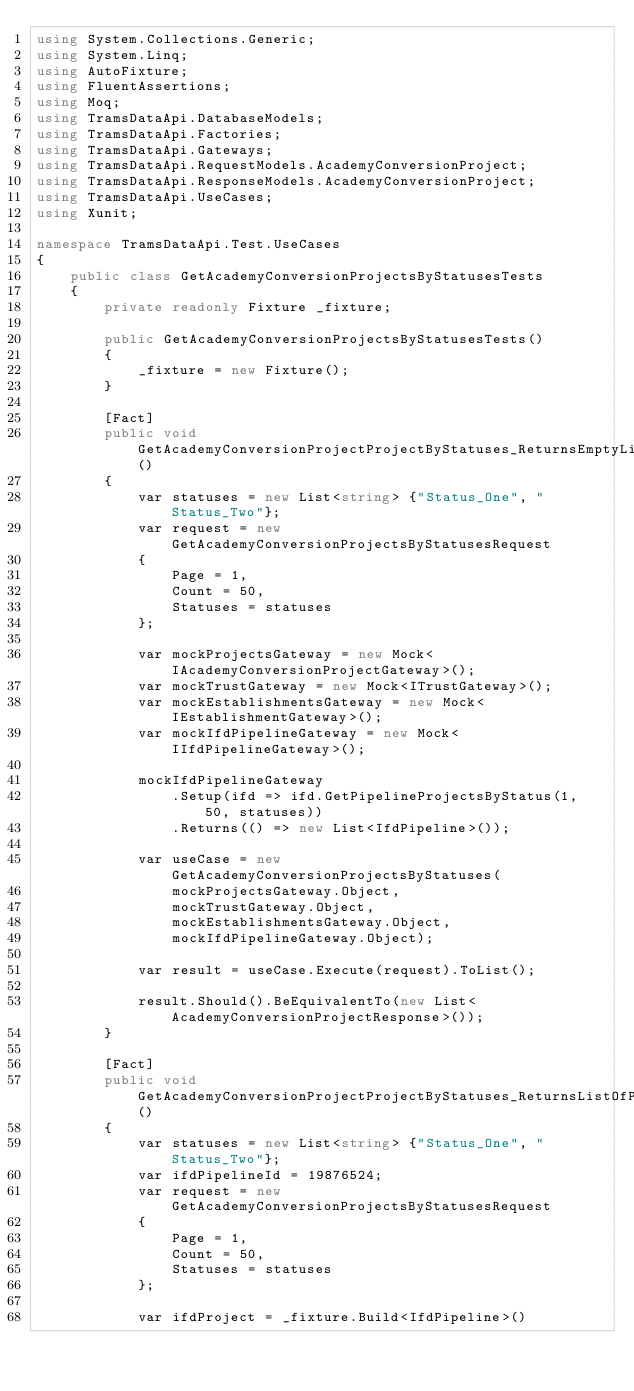Convert code to text. <code><loc_0><loc_0><loc_500><loc_500><_C#_>using System.Collections.Generic;
using System.Linq;
using AutoFixture;
using FluentAssertions;
using Moq;
using TramsDataApi.DatabaseModels;
using TramsDataApi.Factories;
using TramsDataApi.Gateways;
using TramsDataApi.RequestModels.AcademyConversionProject;
using TramsDataApi.ResponseModels.AcademyConversionProject;
using TramsDataApi.UseCases;
using Xunit;

namespace TramsDataApi.Test.UseCases
{
    public class GetAcademyConversionProjectsByStatusesTests
    {
        private readonly Fixture _fixture;

        public GetAcademyConversionProjectsByStatusesTests()
        {
            _fixture = new Fixture();
        }
        
        [Fact]
        public void GetAcademyConversionProjectProjectByStatuses_ReturnsEmptyList_WhenAcademyTransferProjectIsNotFound()
        {
            var statuses = new List<string> {"Status_One", "Status_Two"};
            var request = new GetAcademyConversionProjectsByStatusesRequest
            {
                Page = 1,
                Count = 50,
                Statuses = statuses
            };
            
            var mockProjectsGateway = new Mock<IAcademyConversionProjectGateway>();
            var mockTrustGateway = new Mock<ITrustGateway>();
            var mockEstablishmentsGateway = new Mock<IEstablishmentGateway>();
            var mockIfdPipelineGateway = new Mock<IIfdPipelineGateway>();

            mockIfdPipelineGateway
                .Setup(ifd => ifd.GetPipelineProjectsByStatus(1, 50, statuses))
                .Returns(() => new List<IfdPipeline>());

            var useCase = new GetAcademyConversionProjectsByStatuses(
                mockProjectsGateway.Object, 
                mockTrustGateway.Object,
                mockEstablishmentsGateway.Object,
                mockIfdPipelineGateway.Object);
            
            var result = useCase.Execute(request).ToList();

            result.Should().BeEquivalentTo(new List<AcademyConversionProjectResponse>());
        }
        
        [Fact]
        public void GetAcademyConversionProjectProjectByStatuses_ReturnsListOfProjectResponses_WhenAcademyTransferProjectsAreFound()
        {
            var statuses = new List<string> {"Status_One", "Status_Two"};
            var ifdPipelineId = 19876524;
            var request = new GetAcademyConversionProjectsByStatusesRequest
            {
                Page = 1,
                Count = 50,
                Statuses = statuses
            };
            
            var ifdProject = _fixture.Build<IfdPipeline>()</code> 